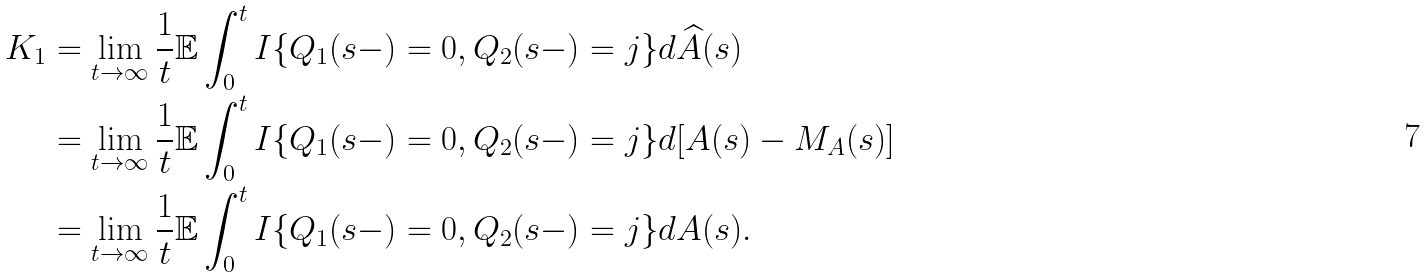<formula> <loc_0><loc_0><loc_500><loc_500>K _ { 1 } & = \lim _ { t \to \infty } \frac { 1 } { t } \mathbb { E } \int _ { 0 } ^ { t } { I } \{ Q _ { 1 } ( s - ) = 0 , Q _ { 2 } ( s - ) = j \} d \widehat { A } ( s ) \\ & = \lim _ { t \to \infty } \frac { 1 } { t } \mathbb { E } \int _ { 0 } ^ { t } { I } \{ Q _ { 1 } ( s - ) = 0 , Q _ { 2 } ( s - ) = j \} d [ A ( s ) - M _ { A } ( s ) ] \\ & = \lim _ { t \to \infty } \frac { 1 } { t } \mathbb { E } \int _ { 0 } ^ { t } { I } \{ Q _ { 1 } ( s - ) = 0 , Q _ { 2 } ( s - ) = j \} d A ( s ) .</formula> 